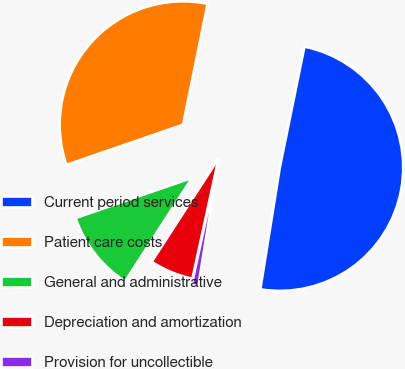Convert chart to OTSL. <chart><loc_0><loc_0><loc_500><loc_500><pie_chart><fcel>Current period services<fcel>Patient care costs<fcel>General and administrative<fcel>Depreciation and amortization<fcel>Provision for uncollectible<nl><fcel>49.33%<fcel>33.48%<fcel>10.57%<fcel>5.73%<fcel>0.88%<nl></chart> 